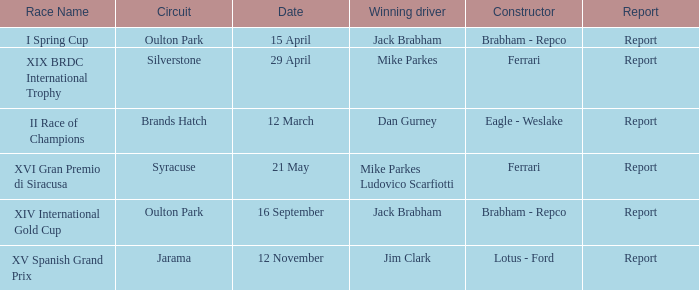What is the circuit held on 15 april? Oulton Park. 